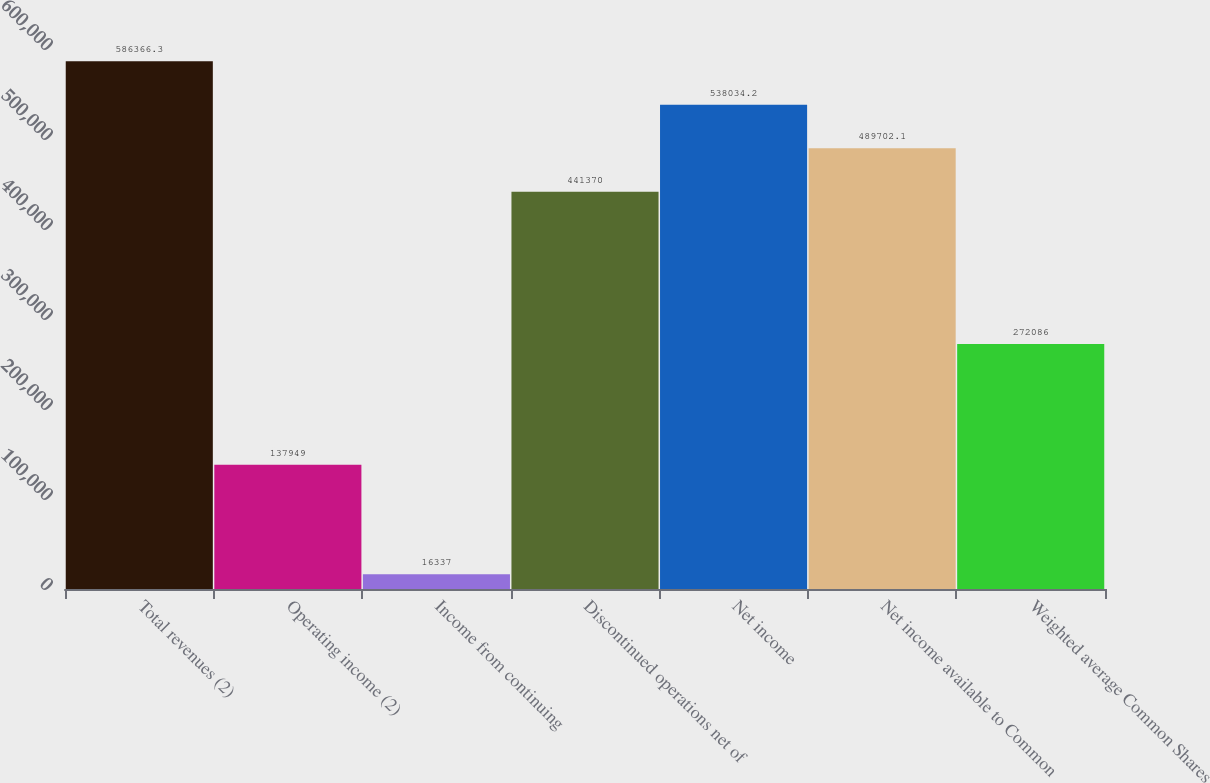Convert chart. <chart><loc_0><loc_0><loc_500><loc_500><bar_chart><fcel>Total revenues (2)<fcel>Operating income (2)<fcel>Income from continuing<fcel>Discontinued operations net of<fcel>Net income<fcel>Net income available to Common<fcel>Weighted average Common Shares<nl><fcel>586366<fcel>137949<fcel>16337<fcel>441370<fcel>538034<fcel>489702<fcel>272086<nl></chart> 